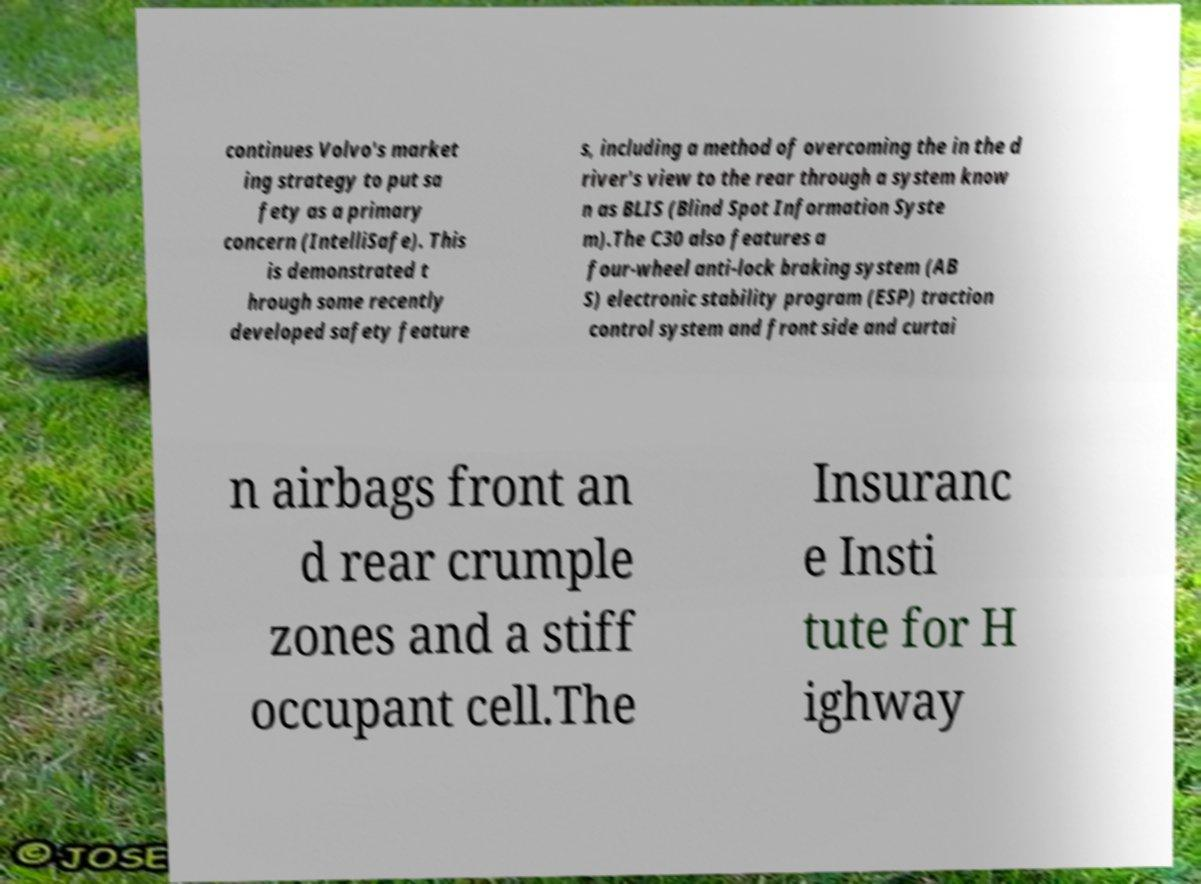Could you assist in decoding the text presented in this image and type it out clearly? continues Volvo's market ing strategy to put sa fety as a primary concern (IntelliSafe). This is demonstrated t hrough some recently developed safety feature s, including a method of overcoming the in the d river's view to the rear through a system know n as BLIS (Blind Spot Information Syste m).The C30 also features a four-wheel anti-lock braking system (AB S) electronic stability program (ESP) traction control system and front side and curtai n airbags front an d rear crumple zones and a stiff occupant cell.The Insuranc e Insti tute for H ighway 